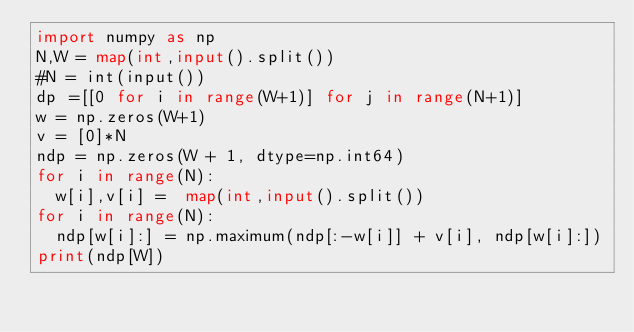<code> <loc_0><loc_0><loc_500><loc_500><_Python_>import numpy as np
N,W = map(int,input().split())
#N = int(input())
dp =[[0 for i in range(W+1)] for j in range(N+1)]
w = np.zeros(W+1)
v = [0]*N
ndp = np.zeros(W + 1, dtype=np.int64)
for i in range(N):
  w[i],v[i] =  map(int,input().split())
for i in range(N):
  ndp[w[i]:] = np.maximum(ndp[:-w[i]] + v[i], ndp[w[i]:])
print(ndp[W])</code> 